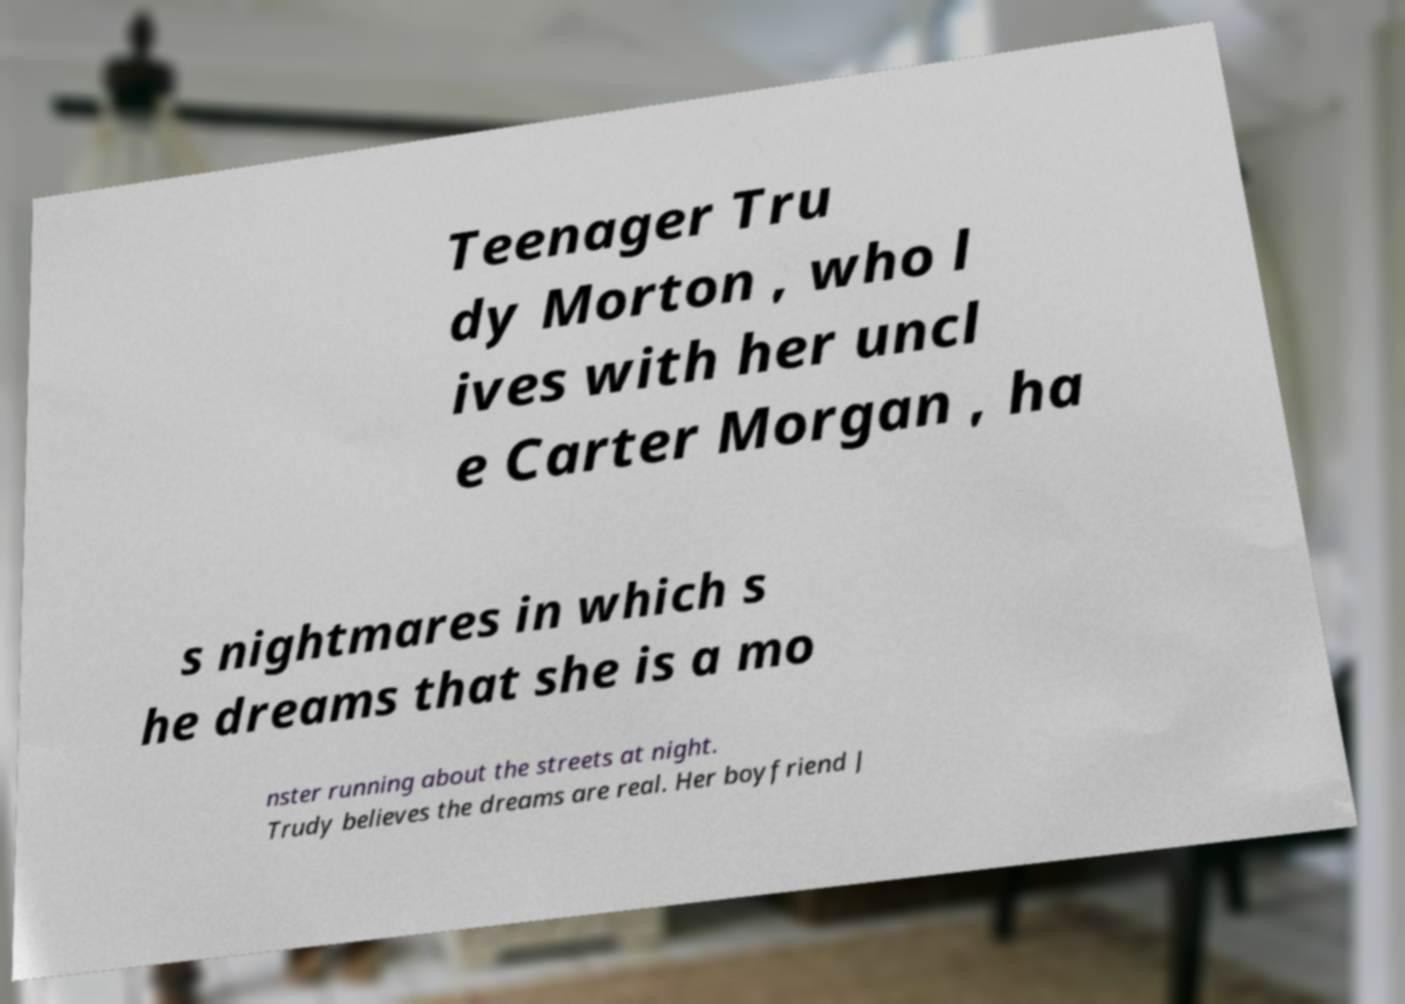What messages or text are displayed in this image? I need them in a readable, typed format. Teenager Tru dy Morton , who l ives with her uncl e Carter Morgan , ha s nightmares in which s he dreams that she is a mo nster running about the streets at night. Trudy believes the dreams are real. Her boyfriend J 